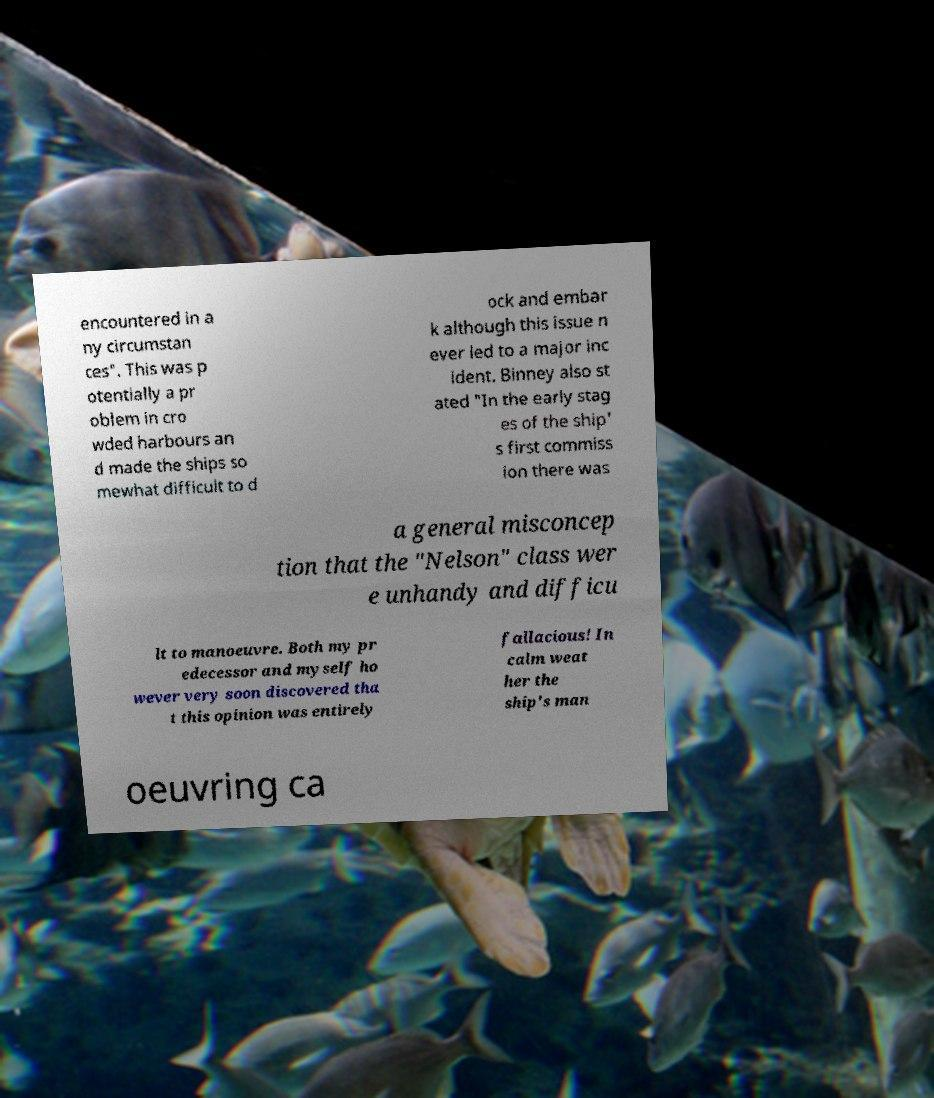I need the written content from this picture converted into text. Can you do that? encountered in a ny circumstan ces". This was p otentially a pr oblem in cro wded harbours an d made the ships so mewhat difficult to d ock and embar k although this issue n ever led to a major inc ident. Binney also st ated "In the early stag es of the ship' s first commiss ion there was a general misconcep tion that the "Nelson" class wer e unhandy and difficu lt to manoeuvre. Both my pr edecessor and myself ho wever very soon discovered tha t this opinion was entirely fallacious! In calm weat her the ship's man oeuvring ca 